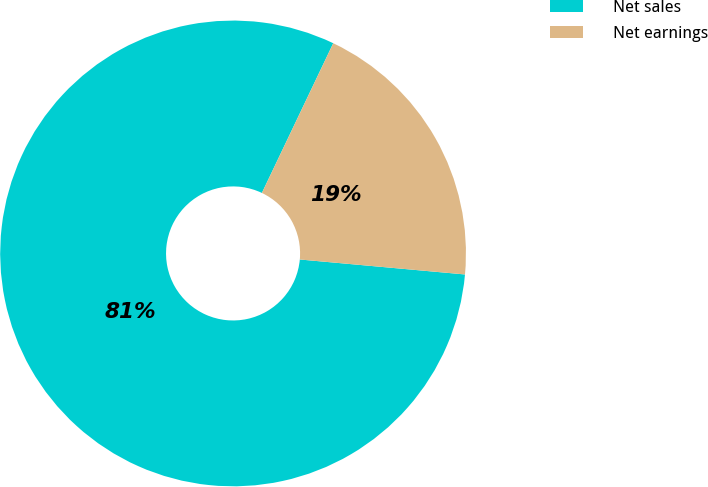Convert chart. <chart><loc_0><loc_0><loc_500><loc_500><pie_chart><fcel>Net sales<fcel>Net earnings<nl><fcel>80.64%<fcel>19.36%<nl></chart> 